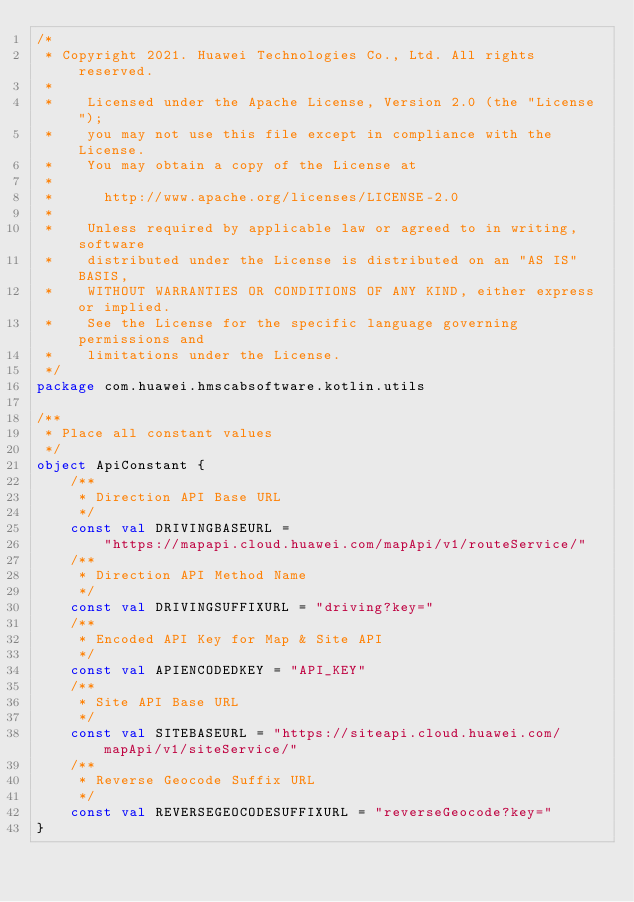<code> <loc_0><loc_0><loc_500><loc_500><_Kotlin_>/*
 * Copyright 2021. Huawei Technologies Co., Ltd. All rights reserved.
 *
 *    Licensed under the Apache License, Version 2.0 (the "License");
 *    you may not use this file except in compliance with the License.
 *    You may obtain a copy of the License at
 *
 *      http://www.apache.org/licenses/LICENSE-2.0
 *
 *    Unless required by applicable law or agreed to in writing, software
 *    distributed under the License is distributed on an "AS IS" BASIS,
 *    WITHOUT WARRANTIES OR CONDITIONS OF ANY KIND, either express or implied.
 *    See the License for the specific language governing permissions and
 *    limitations under the License.
 */
package com.huawei.hmscabsoftware.kotlin.utils

/**
 * Place all constant values
 */
object ApiConstant {
    /**
     * Direction API Base URL
     */
    const val DRIVINGBASEURL =
        "https://mapapi.cloud.huawei.com/mapApi/v1/routeService/"
    /**
     * Direction API Method Name
     */
    const val DRIVINGSUFFIXURL = "driving?key="
    /**
     * Encoded API Key for Map & Site API
     */
    const val APIENCODEDKEY = "API_KEY"
    /**
     * Site API Base URL
     */
    const val SITEBASEURL = "https://siteapi.cloud.huawei.com/mapApi/v1/siteService/"
    /**
     * Reverse Geocode Suffix URL
     */
    const val REVERSEGEOCODESUFFIXURL = "reverseGeocode?key="
}

</code> 